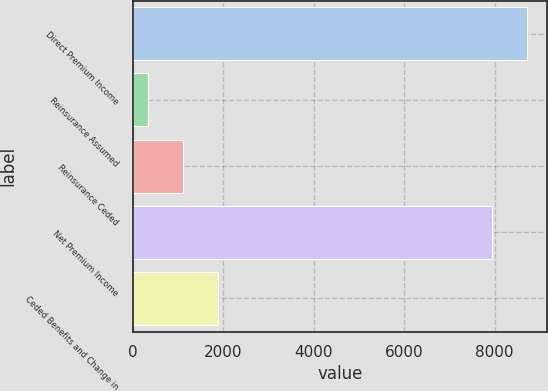Convert chart to OTSL. <chart><loc_0><loc_0><loc_500><loc_500><bar_chart><fcel>Direct Premium Income<fcel>Reinsurance Assumed<fcel>Reinsurance Ceded<fcel>Net Premium Income<fcel>Ceded Benefits and Change in<nl><fcel>8724.03<fcel>324.3<fcel>1100.13<fcel>7948.2<fcel>1875.96<nl></chart> 